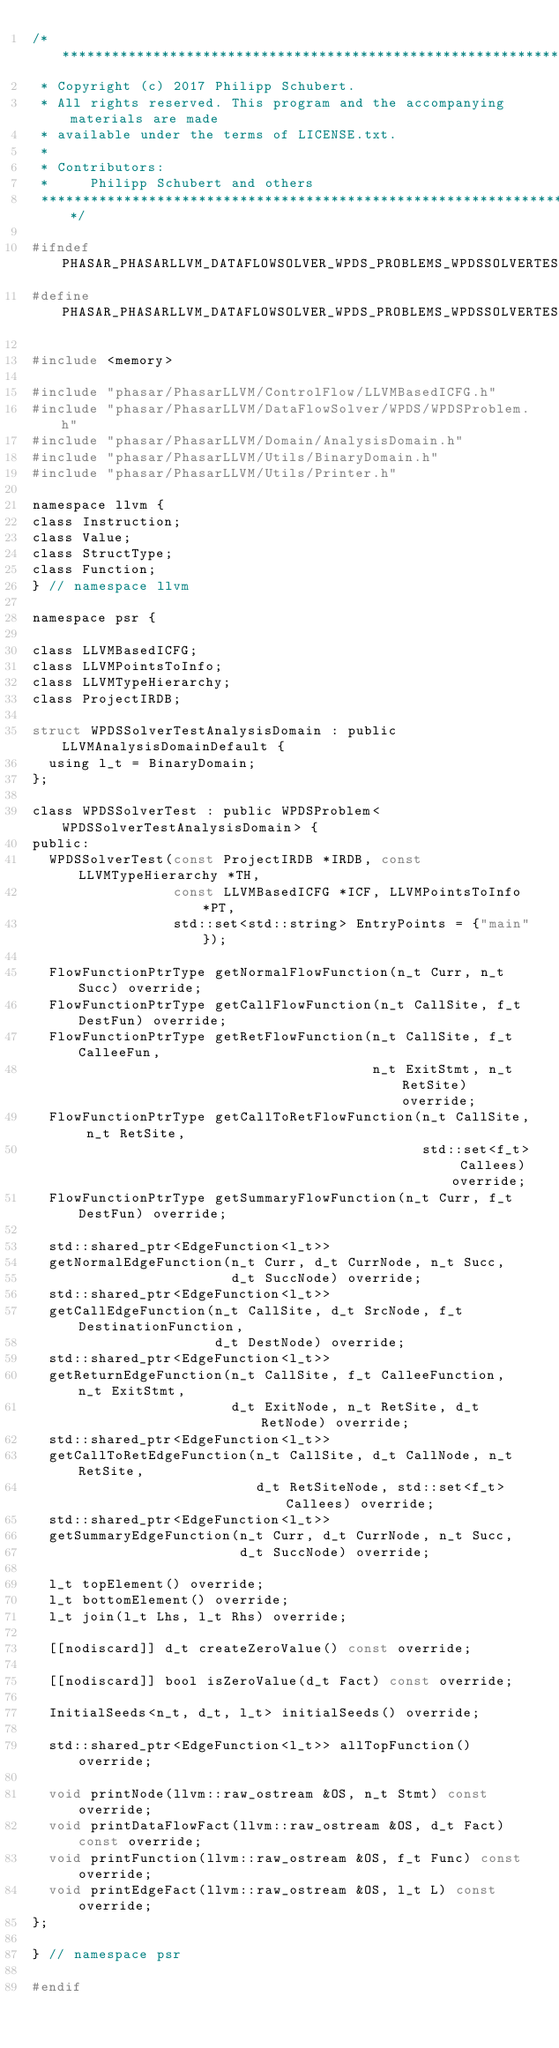<code> <loc_0><loc_0><loc_500><loc_500><_C_>/******************************************************************************
 * Copyright (c) 2017 Philipp Schubert.
 * All rights reserved. This program and the accompanying materials are made
 * available under the terms of LICENSE.txt.
 *
 * Contributors:
 *     Philipp Schubert and others
 *****************************************************************************/

#ifndef PHASAR_PHASARLLVM_DATAFLOWSOLVER_WPDS_PROBLEMS_WPDSSOLVERTEST_H
#define PHASAR_PHASARLLVM_DATAFLOWSOLVER_WPDS_PROBLEMS_WPDSSOLVERTEST_H

#include <memory>

#include "phasar/PhasarLLVM/ControlFlow/LLVMBasedICFG.h"
#include "phasar/PhasarLLVM/DataFlowSolver/WPDS/WPDSProblem.h"
#include "phasar/PhasarLLVM/Domain/AnalysisDomain.h"
#include "phasar/PhasarLLVM/Utils/BinaryDomain.h"
#include "phasar/PhasarLLVM/Utils/Printer.h"

namespace llvm {
class Instruction;
class Value;
class StructType;
class Function;
} // namespace llvm

namespace psr {

class LLVMBasedICFG;
class LLVMPointsToInfo;
class LLVMTypeHierarchy;
class ProjectIRDB;

struct WPDSSolverTestAnalysisDomain : public LLVMAnalysisDomainDefault {
  using l_t = BinaryDomain;
};

class WPDSSolverTest : public WPDSProblem<WPDSSolverTestAnalysisDomain> {
public:
  WPDSSolverTest(const ProjectIRDB *IRDB, const LLVMTypeHierarchy *TH,
                 const LLVMBasedICFG *ICF, LLVMPointsToInfo *PT,
                 std::set<std::string> EntryPoints = {"main"});

  FlowFunctionPtrType getNormalFlowFunction(n_t Curr, n_t Succ) override;
  FlowFunctionPtrType getCallFlowFunction(n_t CallSite, f_t DestFun) override;
  FlowFunctionPtrType getRetFlowFunction(n_t CallSite, f_t CalleeFun,
                                         n_t ExitStmt, n_t RetSite) override;
  FlowFunctionPtrType getCallToRetFlowFunction(n_t CallSite, n_t RetSite,
                                               std::set<f_t> Callees) override;
  FlowFunctionPtrType getSummaryFlowFunction(n_t Curr, f_t DestFun) override;

  std::shared_ptr<EdgeFunction<l_t>>
  getNormalEdgeFunction(n_t Curr, d_t CurrNode, n_t Succ,
                        d_t SuccNode) override;
  std::shared_ptr<EdgeFunction<l_t>>
  getCallEdgeFunction(n_t CallSite, d_t SrcNode, f_t DestinationFunction,
                      d_t DestNode) override;
  std::shared_ptr<EdgeFunction<l_t>>
  getReturnEdgeFunction(n_t CallSite, f_t CalleeFunction, n_t ExitStmt,
                        d_t ExitNode, n_t RetSite, d_t RetNode) override;
  std::shared_ptr<EdgeFunction<l_t>>
  getCallToRetEdgeFunction(n_t CallSite, d_t CallNode, n_t RetSite,
                           d_t RetSiteNode, std::set<f_t> Callees) override;
  std::shared_ptr<EdgeFunction<l_t>>
  getSummaryEdgeFunction(n_t Curr, d_t CurrNode, n_t Succ,
                         d_t SuccNode) override;

  l_t topElement() override;
  l_t bottomElement() override;
  l_t join(l_t Lhs, l_t Rhs) override;

  [[nodiscard]] d_t createZeroValue() const override;

  [[nodiscard]] bool isZeroValue(d_t Fact) const override;

  InitialSeeds<n_t, d_t, l_t> initialSeeds() override;

  std::shared_ptr<EdgeFunction<l_t>> allTopFunction() override;

  void printNode(llvm::raw_ostream &OS, n_t Stmt) const override;
  void printDataFlowFact(llvm::raw_ostream &OS, d_t Fact) const override;
  void printFunction(llvm::raw_ostream &OS, f_t Func) const override;
  void printEdgeFact(llvm::raw_ostream &OS, l_t L) const override;
};

} // namespace psr

#endif
</code> 